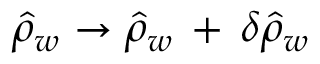<formula> <loc_0><loc_0><loc_500><loc_500>\hat { \rho } _ { w } \to \hat { \rho } _ { w } \, + \, \delta \hat { \rho } _ { w }</formula> 